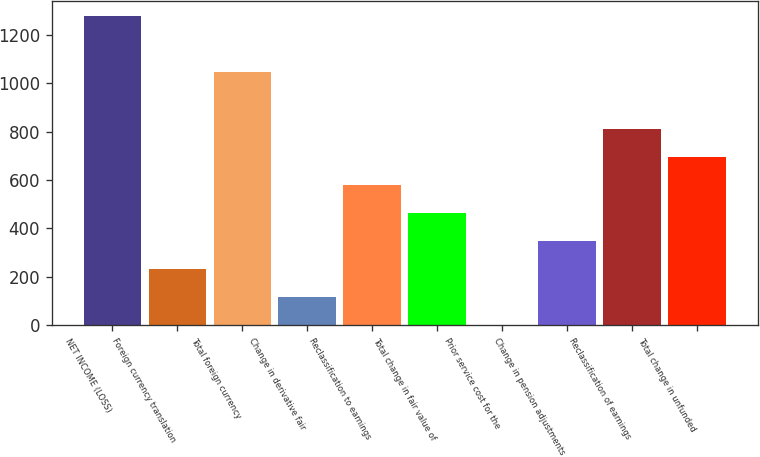Convert chart to OTSL. <chart><loc_0><loc_0><loc_500><loc_500><bar_chart><fcel>NET INCOME (LOSS)<fcel>Foreign currency translation<fcel>Total foreign currency<fcel>Change in derivative fair<fcel>Reclassification to earnings<fcel>Total change in fair value of<fcel>Prior service cost for the<fcel>Change in pension adjustments<fcel>Reclassification of earnings<fcel>Total change in unfunded<nl><fcel>1277<fcel>233<fcel>1045<fcel>117<fcel>581<fcel>465<fcel>1<fcel>349<fcel>813<fcel>697<nl></chart> 